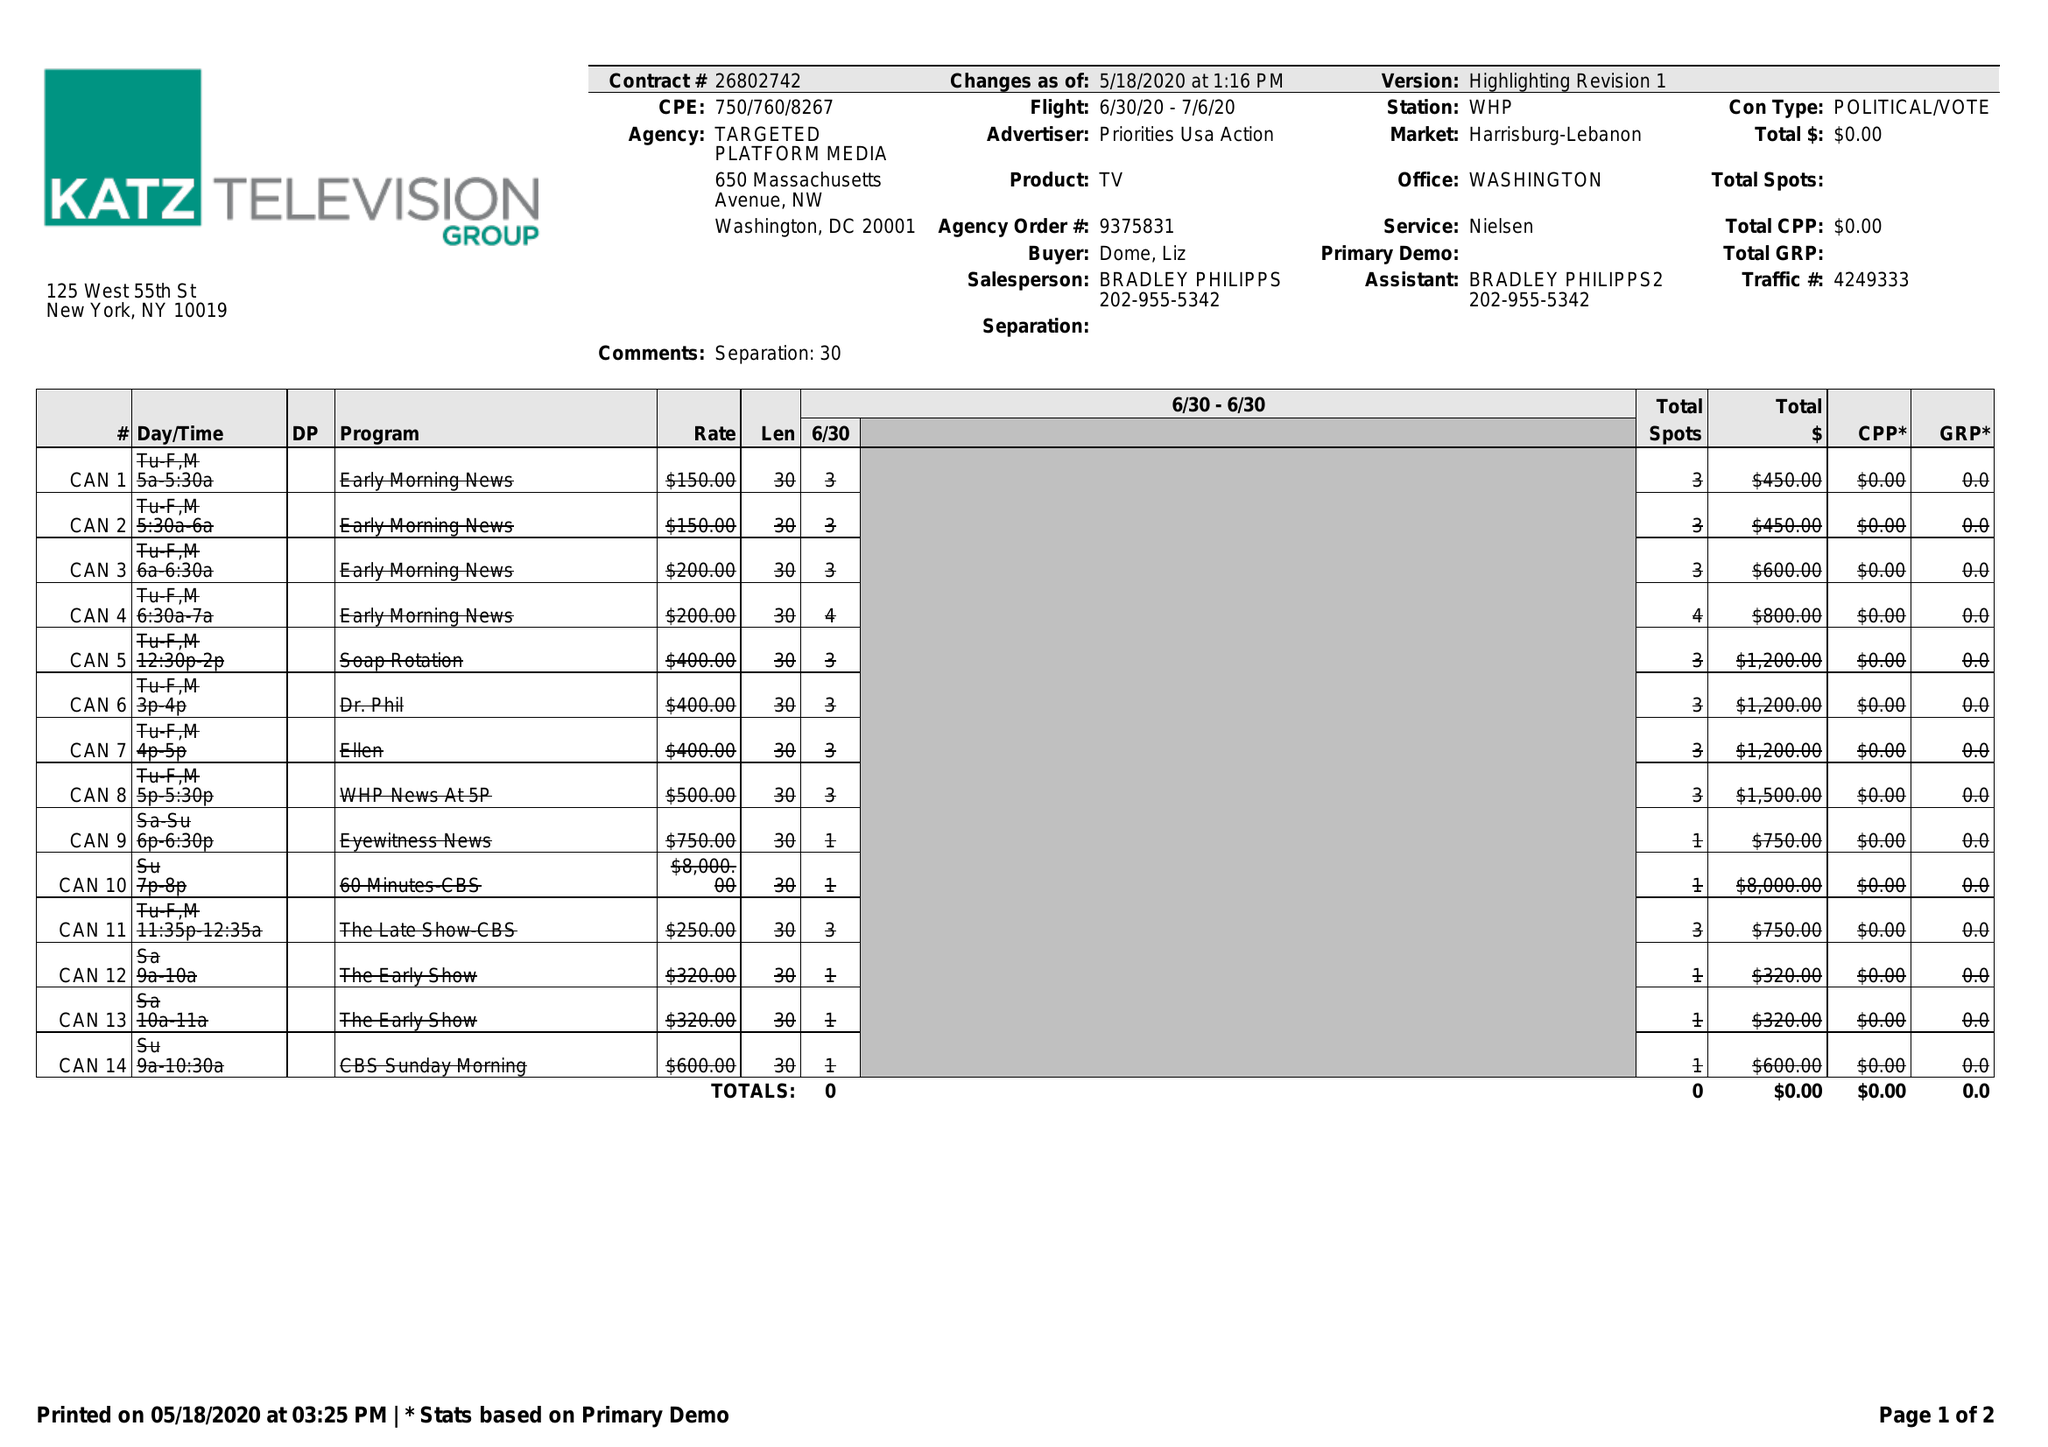What is the value for the flight_to?
Answer the question using a single word or phrase. 07/06/20 